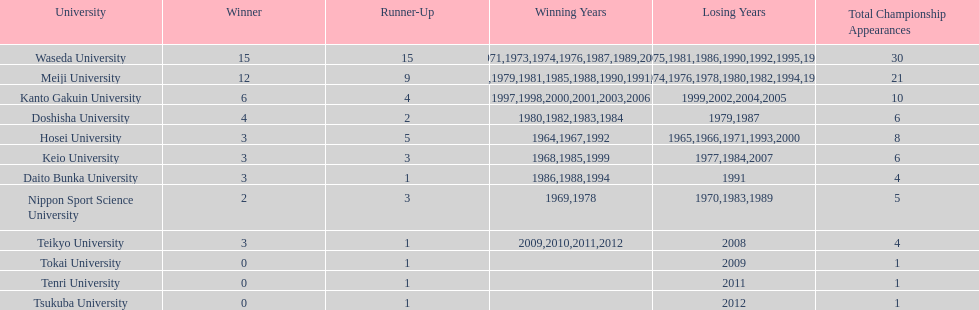Which university had the most years won? Waseda University. 